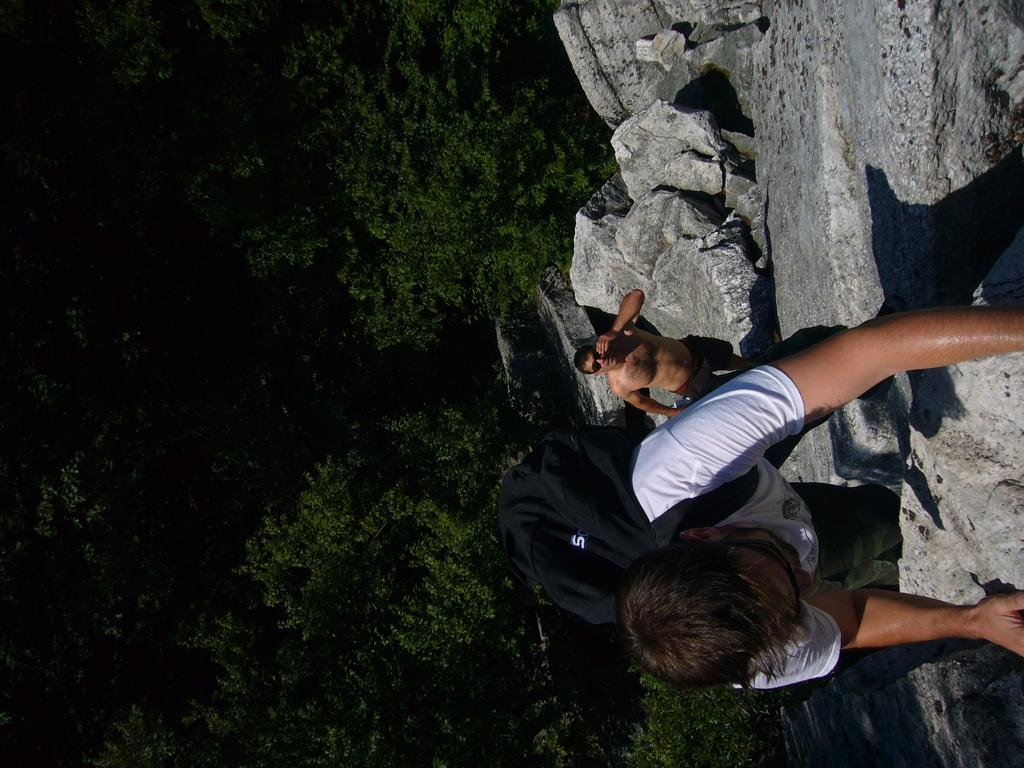How many people are in the image? There are two people in the image. What is one person doing in the image? One person is climbing. What is the person climbing wearing? The person climbing is wearing a black bag. What can be seen in the background of the image? There are trees visible in the image. What type of sail can be seen on the person climbing in the image? There is no sail present in the image; the person is climbing, not sailing. 